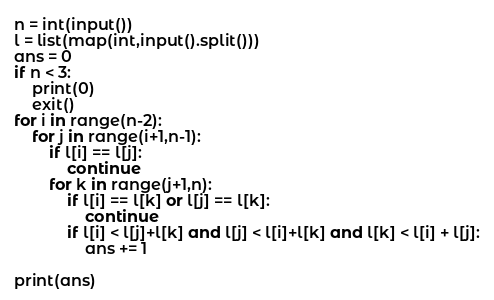<code> <loc_0><loc_0><loc_500><loc_500><_Python_>n = int(input())
l = list(map(int,input().split()))
ans = 0
if n < 3:
    print(0)
    exit()
for i in range(n-2):
    for j in range(i+1,n-1):
        if l[i] == l[j]:
            continue
        for k in range(j+1,n):
            if l[i] == l[k] or l[j] == l[k]:
                continue
            if l[i] < l[j]+l[k] and l[j] < l[i]+l[k] and l[k] < l[i] + l[j]:
                ans += 1

print(ans) </code> 